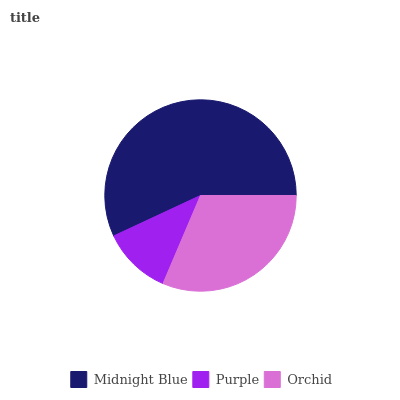Is Purple the minimum?
Answer yes or no. Yes. Is Midnight Blue the maximum?
Answer yes or no. Yes. Is Orchid the minimum?
Answer yes or no. No. Is Orchid the maximum?
Answer yes or no. No. Is Orchid greater than Purple?
Answer yes or no. Yes. Is Purple less than Orchid?
Answer yes or no. Yes. Is Purple greater than Orchid?
Answer yes or no. No. Is Orchid less than Purple?
Answer yes or no. No. Is Orchid the high median?
Answer yes or no. Yes. Is Orchid the low median?
Answer yes or no. Yes. Is Purple the high median?
Answer yes or no. No. Is Midnight Blue the low median?
Answer yes or no. No. 